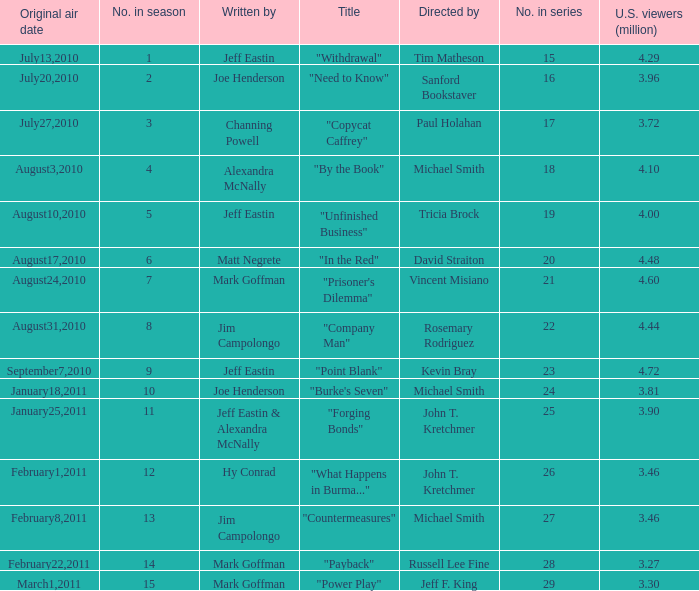How many millions of people in the US watched when Kevin Bray was director? 4.72. 